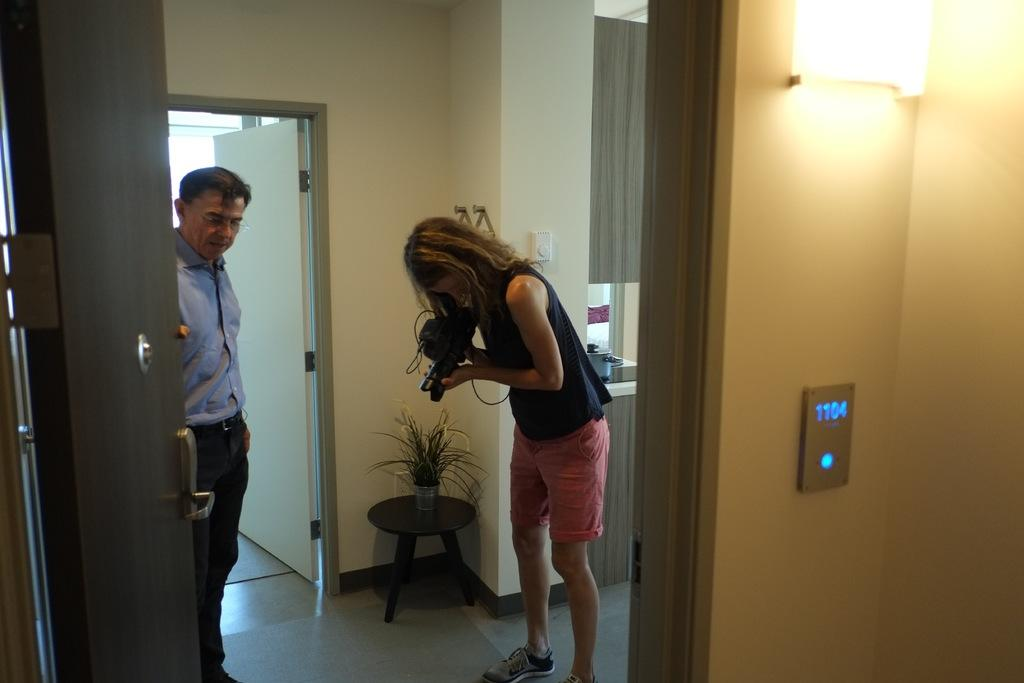How many people are present in the image? There are two people in the image, a man and a woman. What is the woman holding in her hand? The woman is holding a camera in her hand. What type of oven can be seen in the image? There is no oven present in the image. What type of authority does the woman have in the image? The image does not provide any information about the woman's authority. 